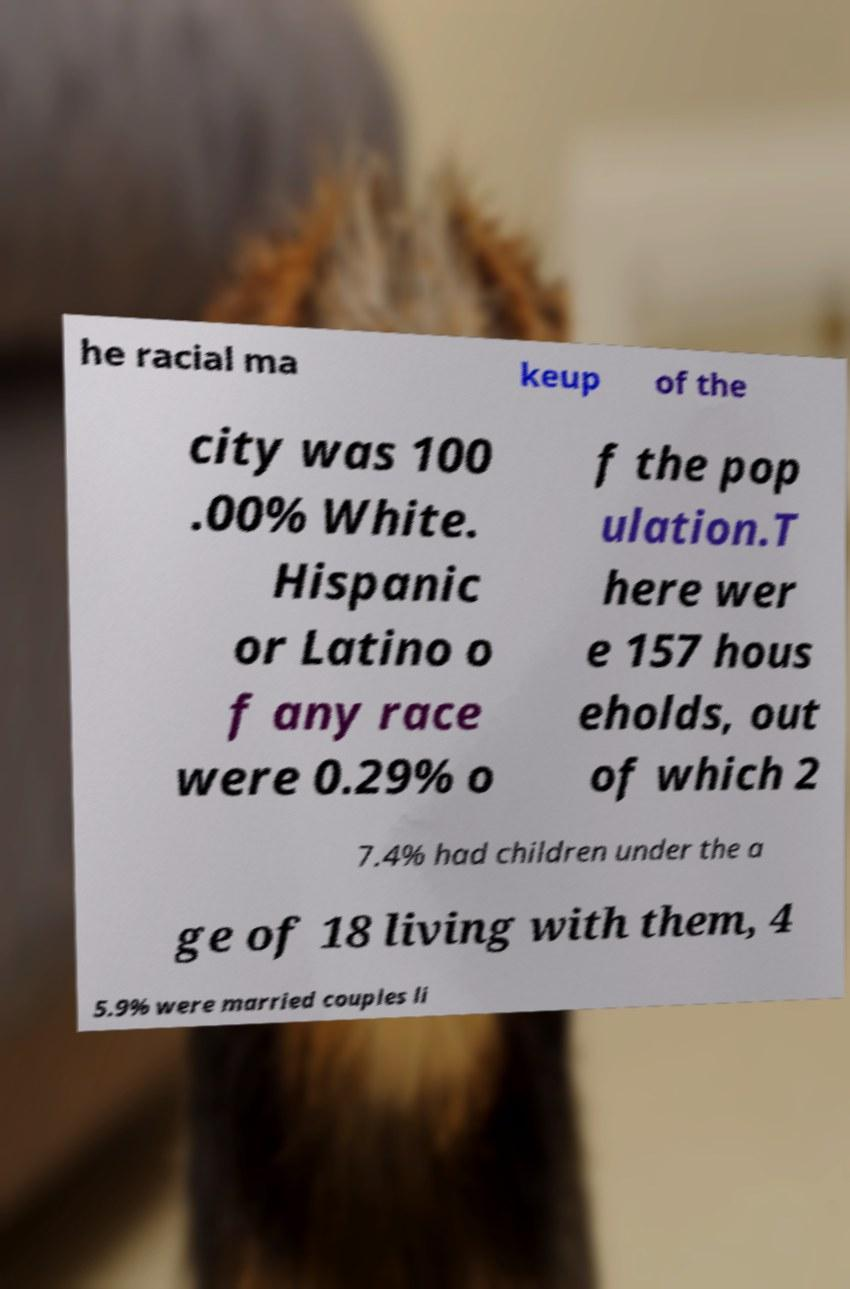There's text embedded in this image that I need extracted. Can you transcribe it verbatim? he racial ma keup of the city was 100 .00% White. Hispanic or Latino o f any race were 0.29% o f the pop ulation.T here wer e 157 hous eholds, out of which 2 7.4% had children under the a ge of 18 living with them, 4 5.9% were married couples li 